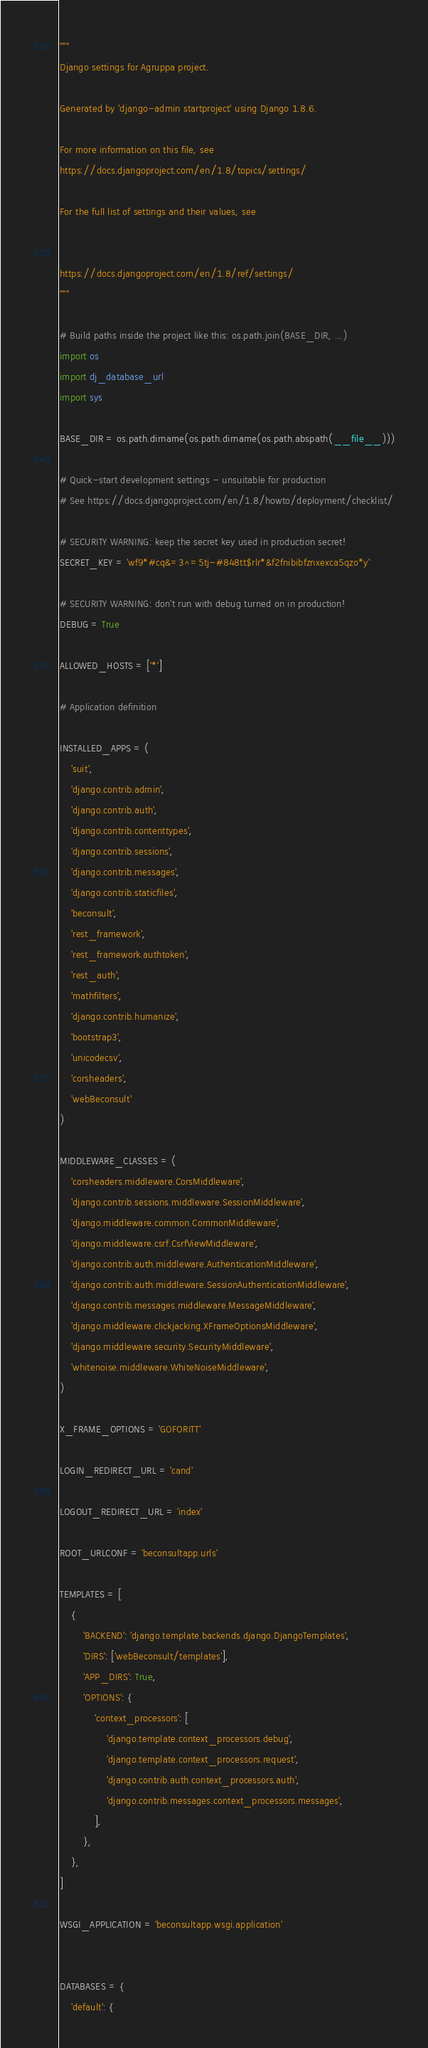Convert code to text. <code><loc_0><loc_0><loc_500><loc_500><_Python_>"""
Django settings for Agruppa project.

Generated by 'django-admin startproject' using Django 1.8.6.

For more information on this file, see
https://docs.djangoproject.com/en/1.8/topics/settings/

For the full list of settings and their values, see


https://docs.djangoproject.com/en/1.8/ref/settings/
"""

# Build paths inside the project like this: os.path.join(BASE_DIR, ...)
import os
import dj_database_url
import sys

BASE_DIR = os.path.dirname(os.path.dirname(os.path.abspath(__file__)))

# Quick-start development settings - unsuitable for production
# See https://docs.djangoproject.com/en/1.8/howto/deployment/checklist/

# SECURITY WARNING: keep the secret key used in production secret!
SECRET_KEY = 'wf9*#cq&=3^=5tj-#848tt$rlr*&f2fnibibfznxexca5qzo*y'

# SECURITY WARNING: don't run with debug turned on in production!
DEBUG = True

ALLOWED_HOSTS = ['*']

# Application definition

INSTALLED_APPS = (
    'suit',
    'django.contrib.admin',
    'django.contrib.auth',
    'django.contrib.contenttypes',
    'django.contrib.sessions',
    'django.contrib.messages',
    'django.contrib.staticfiles',
    'beconsult',
    'rest_framework',
    'rest_framework.authtoken',
    'rest_auth',
    'mathfilters',
    'django.contrib.humanize',
    'bootstrap3',
    'unicodecsv',
    'corsheaders',
    'webBeconsult'
)

MIDDLEWARE_CLASSES = (
    'corsheaders.middleware.CorsMiddleware',
    'django.contrib.sessions.middleware.SessionMiddleware',
    'django.middleware.common.CommonMiddleware',
    'django.middleware.csrf.CsrfViewMiddleware',
    'django.contrib.auth.middleware.AuthenticationMiddleware',
    'django.contrib.auth.middleware.SessionAuthenticationMiddleware',
    'django.contrib.messages.middleware.MessageMiddleware',
    'django.middleware.clickjacking.XFrameOptionsMiddleware',
    'django.middleware.security.SecurityMiddleware',
    'whitenoise.middleware.WhiteNoiseMiddleware',
)

X_FRAME_OPTIONS = 'GOFORITT'

LOGIN_REDIRECT_URL = 'cand'

LOGOUT_REDIRECT_URL = 'index'

ROOT_URLCONF = 'beconsultapp.urls'

TEMPLATES = [
    {
        'BACKEND': 'django.template.backends.django.DjangoTemplates',
        'DIRS': ['webBeconsult/templates'],
        'APP_DIRS': True,
        'OPTIONS': {
            'context_processors': [
                'django.template.context_processors.debug',
                'django.template.context_processors.request',
                'django.contrib.auth.context_processors.auth',
                'django.contrib.messages.context_processors.messages',
            ],
        },
    },
]

WSGI_APPLICATION = 'beconsultapp.wsgi.application'


DATABASES = {
    'default': {</code> 